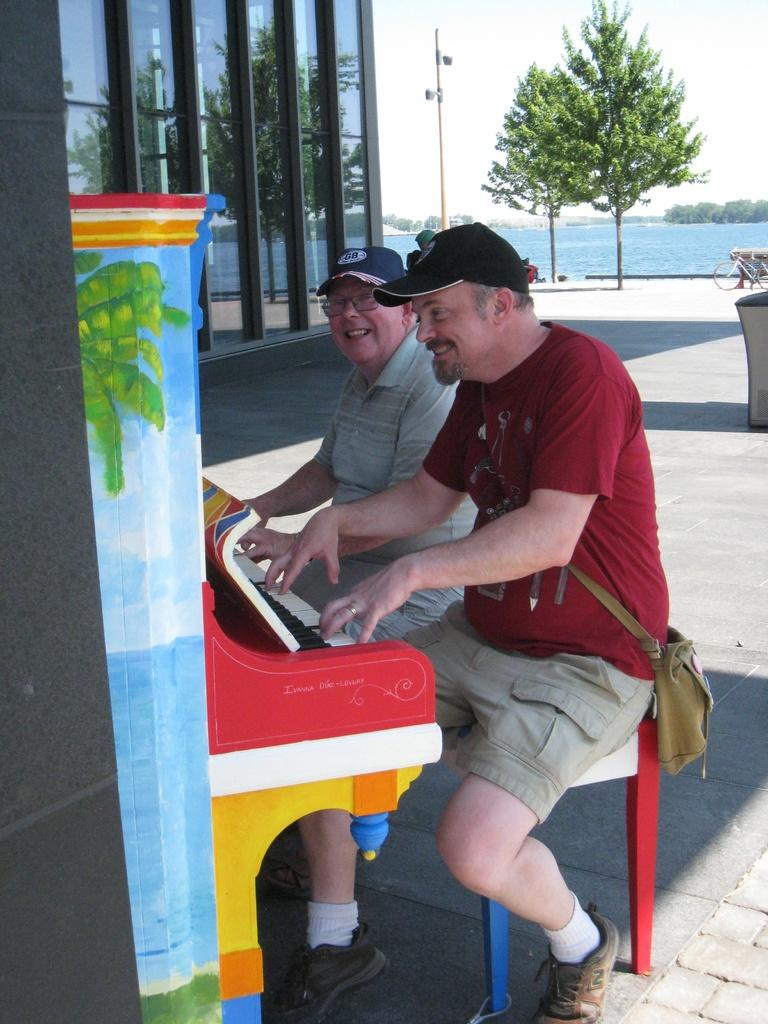How many persons are in the image? There are two persons in the image. What are the persons doing in the image? The persons are sitting in chairs, and one of them is playing a piano. What can be seen in the background of the image? There is a building, a pole, a tree, a beach, sky, and a bicycle visible in the background of the image. What is the number of beginner laughs heard in the image? There is no sound or laughter present in the image, so it is not possible to determine the number of beginner laughs. 